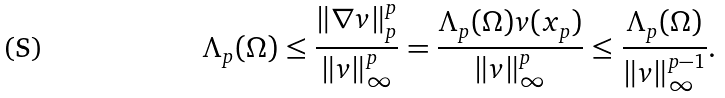Convert formula to latex. <formula><loc_0><loc_0><loc_500><loc_500>\Lambda _ { p } ( \Omega ) \leq \frac { \left \| \nabla v \right \| _ { p } ^ { p } } { \left \| v \right \| _ { \infty } ^ { p } } = \frac { \Lambda _ { p } ( \Omega ) v ( x _ { p } ) } { \left \| v \right \| _ { \infty } ^ { p } } \leq \frac { \Lambda _ { p } ( \Omega ) } { \left \| v \right \| _ { \infty } ^ { p - 1 } } .</formula> 